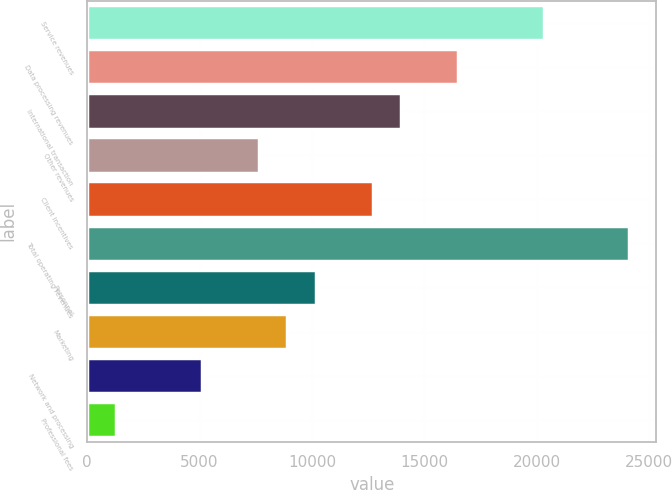<chart> <loc_0><loc_0><loc_500><loc_500><bar_chart><fcel>Service revenues<fcel>Data processing revenues<fcel>International transaction<fcel>Other revenues<fcel>Client incentives<fcel>Total operating revenues<fcel>Personnel<fcel>Marketing<fcel>Network and processing<fcel>Professional fees<nl><fcel>20307<fcel>16504.5<fcel>13969.5<fcel>7632<fcel>12702<fcel>24109.5<fcel>10167<fcel>8899.5<fcel>5097<fcel>1294.5<nl></chart> 